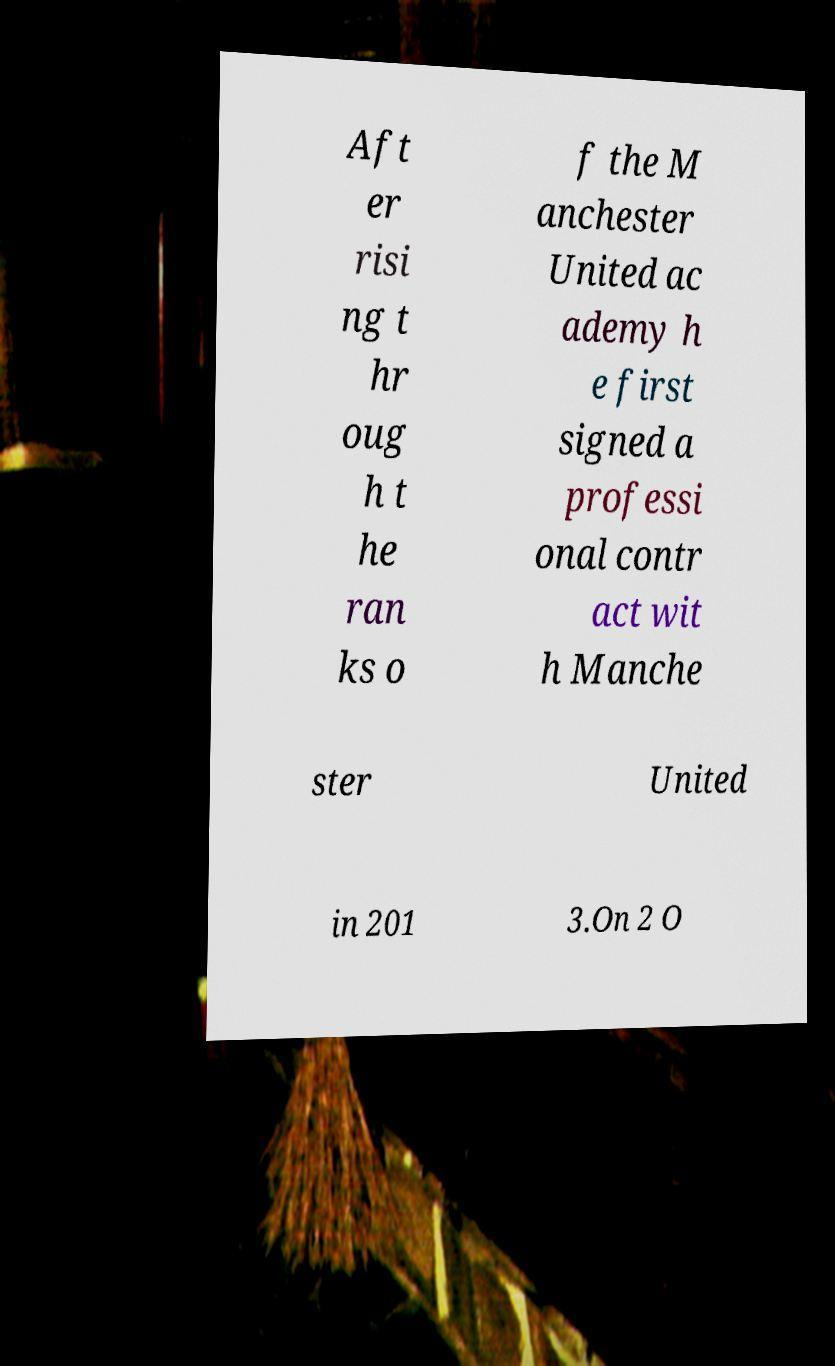Could you assist in decoding the text presented in this image and type it out clearly? Aft er risi ng t hr oug h t he ran ks o f the M anchester United ac ademy h e first signed a professi onal contr act wit h Manche ster United in 201 3.On 2 O 